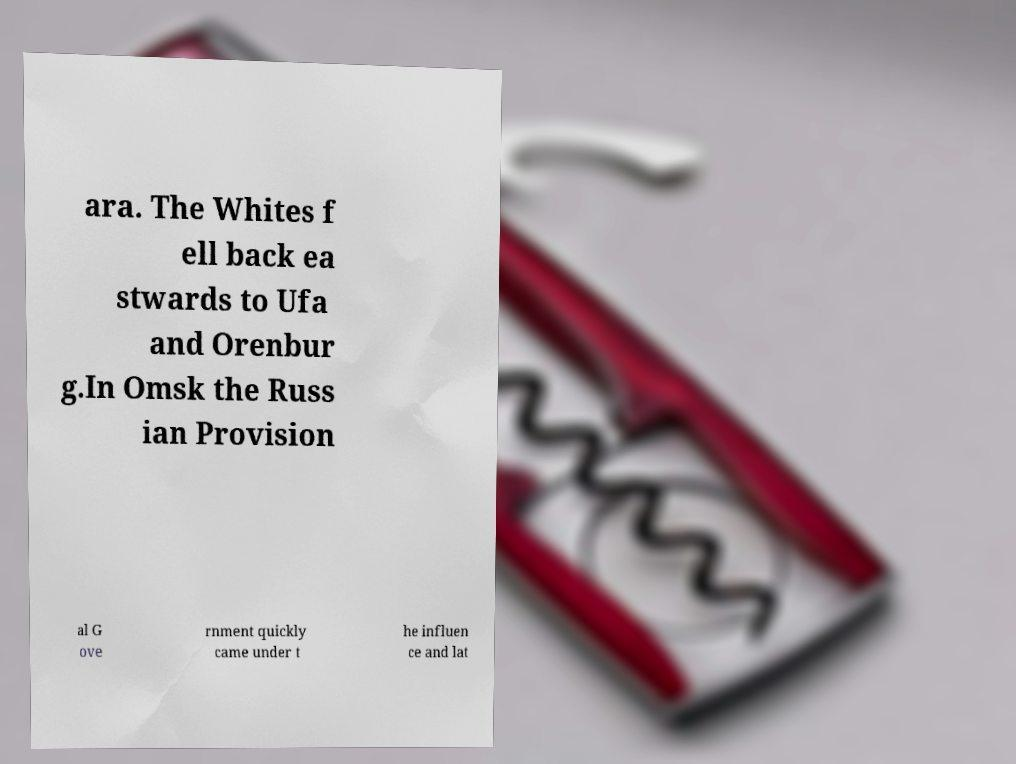Could you assist in decoding the text presented in this image and type it out clearly? ara. The Whites f ell back ea stwards to Ufa and Orenbur g.In Omsk the Russ ian Provision al G ove rnment quickly came under t he influen ce and lat 